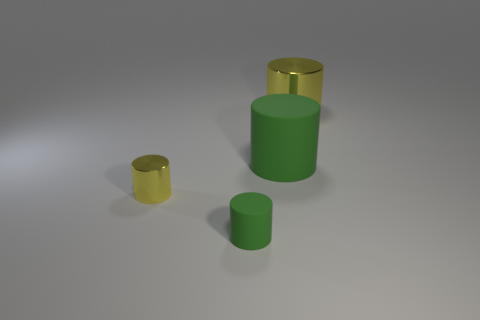Subtract 1 cylinders. How many cylinders are left? 3 Add 4 big blue matte cylinders. How many objects exist? 8 Subtract 0 red cylinders. How many objects are left? 4 Subtract all purple matte spheres. Subtract all small green things. How many objects are left? 3 Add 4 small things. How many small things are left? 6 Add 1 green rubber objects. How many green rubber objects exist? 3 